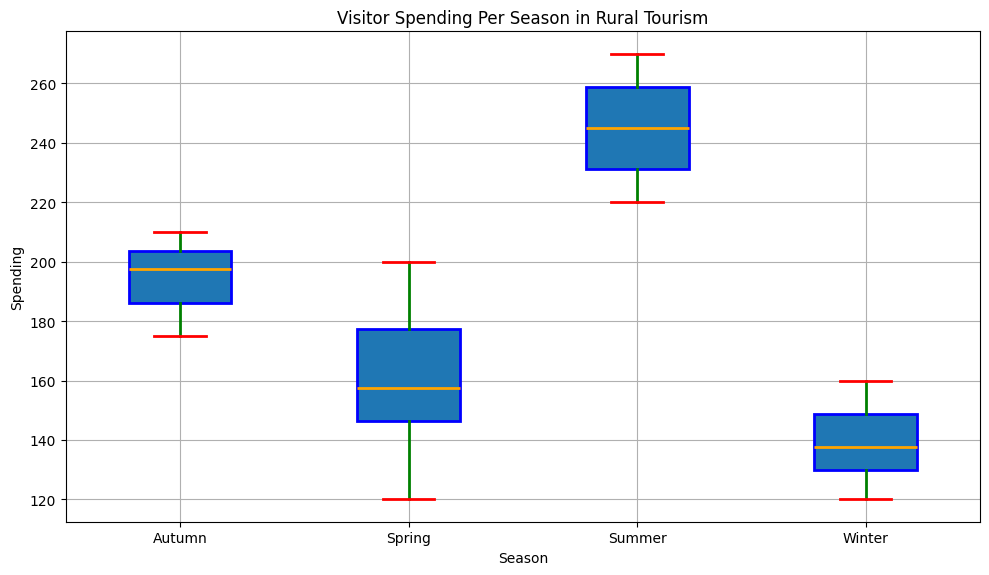What season has the highest median visitor spending? The figure shows four box plots, one for each season. The median is indicated by the orange line inside each box. By comparing the positions of these lines, we can see that the median is highest for Summer.
Answer: Summer What is the interquartile range (IQR) for Autumn? The IQR is the distance between the first quartile (bottom of the box) and the third quartile (top of the box). By looking at the box plot for Autumn, we estimate the first quartile is around 180 and the third quartile is around 205. The IQR is 205 - 180 = 25.
Answer: 25 Which season has the widest range of visitor spending? The range is determined by the distance between the smallest and largest whiskers. Comparing the whiskers in the box plots, Summer shows the widest spread from 220 to 270, making the range 50.
Answer: Summer How does the median spending in Winter compare to the median spending in Spring? Referring to the medians indicated by the orange lines in both Winter and Spring box plots, Winter's median is around 135, and Spring's median is around 155. So, Winter's median spending is less than Spring's.
Answer: Winter is less What is the difference between the maximum visitor spending in Spring and the maximum in Winter? The maximum spending for Spring is shown at the top end of the whisker, which is 200. The maximum for Winter is 160. Therefore, the difference is 200 - 160 = 40.
Answer: 40 What is the minimum spending in Summer? The minimum spending in Summer is indicated by the bottom whisker of the Summer box plot, which is 220.
Answer: 220 In which season is the median visitor spending closest to 150? From the orange median lines, Winter's median spending is closest to 150, being just above 135.
Answer: Winter 